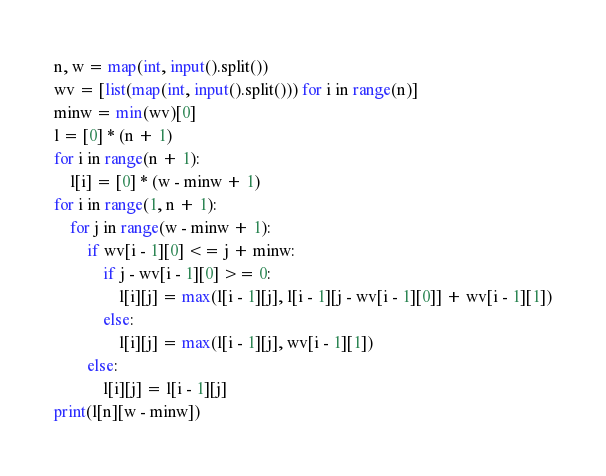Convert code to text. <code><loc_0><loc_0><loc_500><loc_500><_Python_>n, w = map(int, input().split())
wv = [list(map(int, input().split())) for i in range(n)]
minw = min(wv)[0]
l = [0] * (n + 1)
for i in range(n + 1):
    l[i] = [0] * (w - minw + 1)
for i in range(1, n + 1):
    for j in range(w - minw + 1):
        if wv[i - 1][0] <= j + minw:
            if j - wv[i - 1][0] >= 0:
                l[i][j] = max(l[i - 1][j], l[i - 1][j - wv[i - 1][0]] + wv[i - 1][1])
            else:
                l[i][j] = max(l[i - 1][j], wv[i - 1][1])
        else:
            l[i][j] = l[i - 1][j]
print(l[n][w - minw])
</code> 